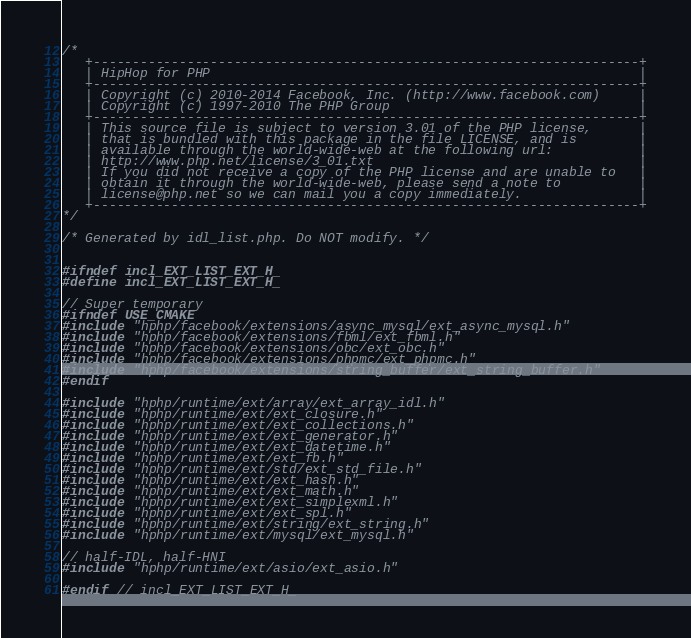Convert code to text. <code><loc_0><loc_0><loc_500><loc_500><_C_>/*
   +----------------------------------------------------------------------+
   | HipHop for PHP                                                       |
   +----------------------------------------------------------------------+
   | Copyright (c) 2010-2014 Facebook, Inc. (http://www.facebook.com)     |
   | Copyright (c) 1997-2010 The PHP Group                                |
   +----------------------------------------------------------------------+
   | This source file is subject to version 3.01 of the PHP license,      |
   | that is bundled with this package in the file LICENSE, and is        |
   | available through the world-wide-web at the following url:           |
   | http://www.php.net/license/3_01.txt                                  |
   | If you did not receive a copy of the PHP license and are unable to   |
   | obtain it through the world-wide-web, please send a note to          |
   | license@php.net so we can mail you a copy immediately.               |
   +----------------------------------------------------------------------+
*/

/* Generated by idl_list.php. Do NOT modify. */


#ifndef incl_EXT_LIST_EXT_H_
#define incl_EXT_LIST_EXT_H_

// Super temporary
#ifndef USE_CMAKE
#include "hphp/facebook/extensions/async_mysql/ext_async_mysql.h"
#include "hphp/facebook/extensions/fbml/ext_fbml.h"
#include "hphp/facebook/extensions/obc/ext_obc.h"
#include "hphp/facebook/extensions/phpmc/ext_phpmc.h"
#include "hphp/facebook/extensions/string_buffer/ext_string_buffer.h"
#endif

#include "hphp/runtime/ext/array/ext_array_idl.h"
#include "hphp/runtime/ext/ext_closure.h"
#include "hphp/runtime/ext/ext_collections.h"
#include "hphp/runtime/ext/ext_generator.h"
#include "hphp/runtime/ext/ext_datetime.h"
#include "hphp/runtime/ext/ext_fb.h"
#include "hphp/runtime/ext/std/ext_std_file.h"
#include "hphp/runtime/ext/ext_hash.h"
#include "hphp/runtime/ext/ext_math.h"
#include "hphp/runtime/ext/ext_simplexml.h"
#include "hphp/runtime/ext/ext_spl.h"
#include "hphp/runtime/ext/string/ext_string.h"
#include "hphp/runtime/ext/mysql/ext_mysql.h"

// half-IDL, half-HNI
#include "hphp/runtime/ext/asio/ext_asio.h"

#endif // incl_EXT_LIST_EXT_H_
</code> 